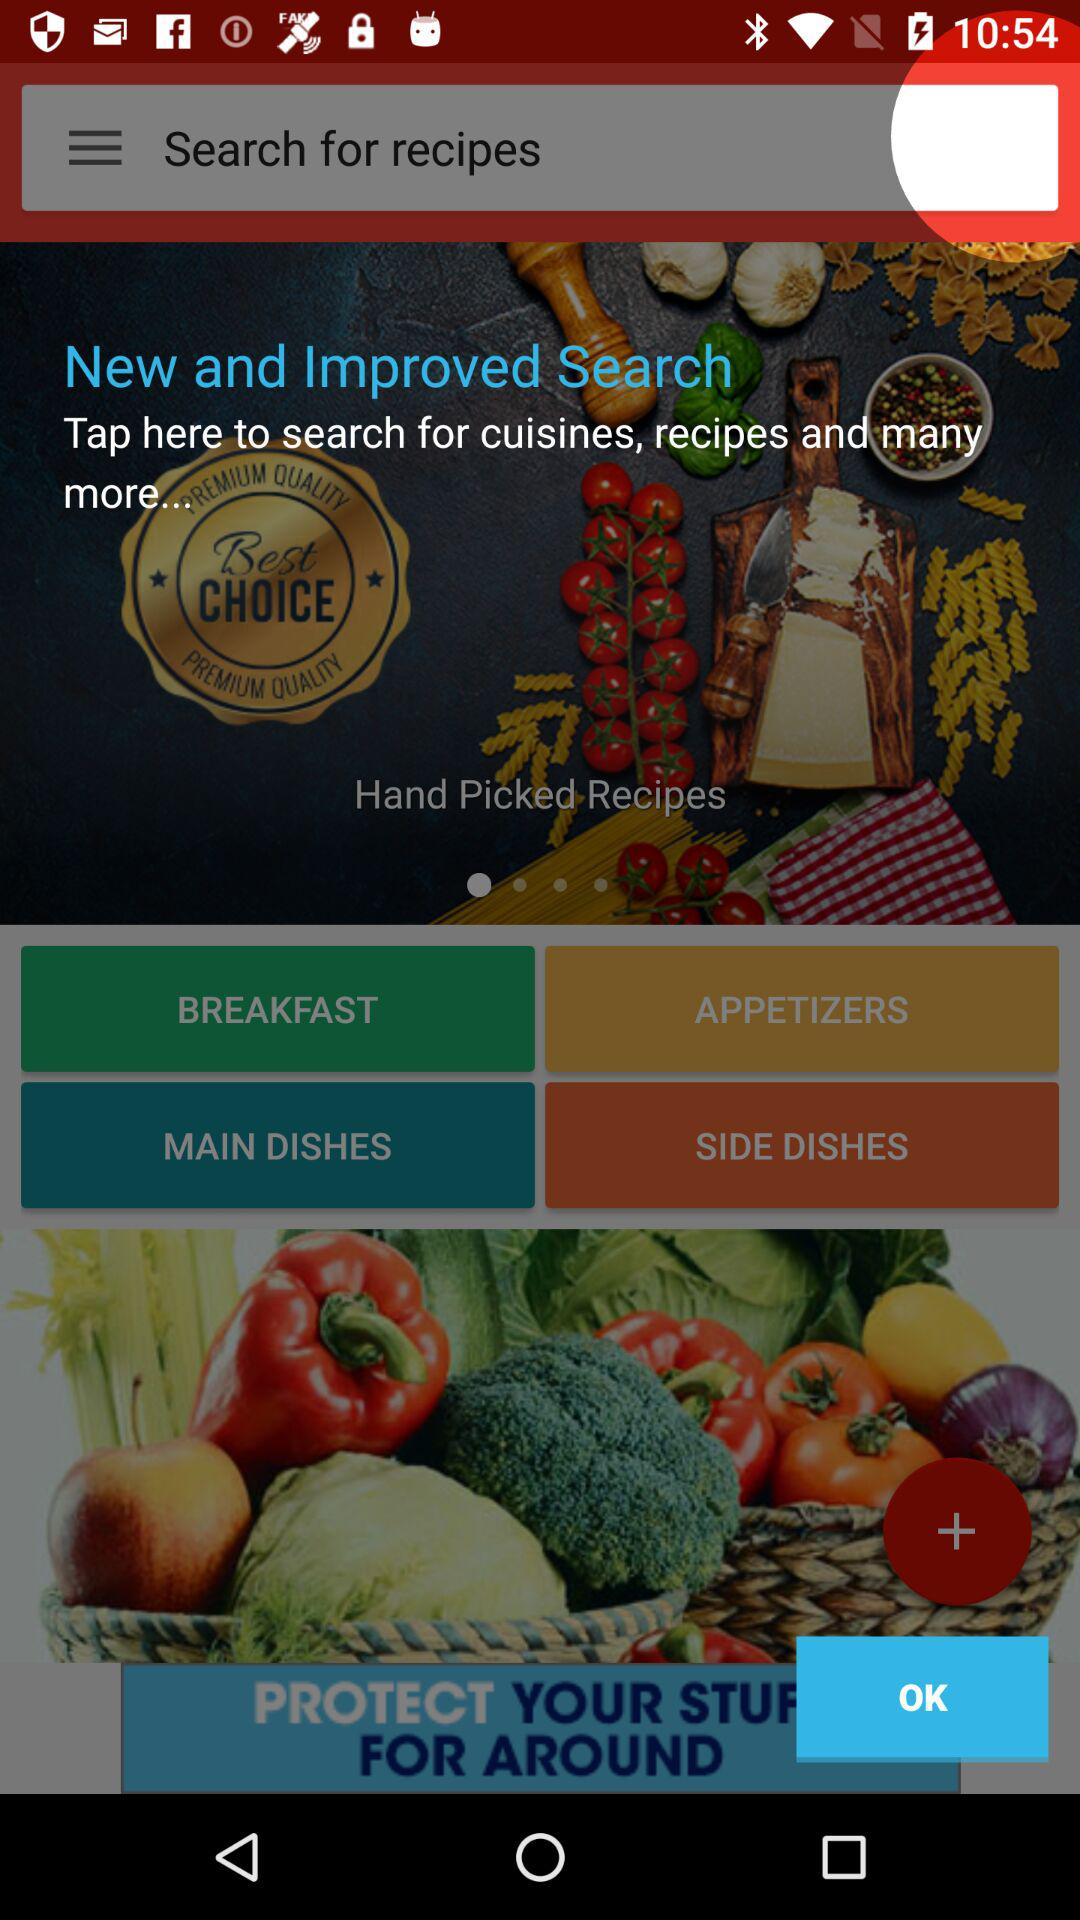What types of dishes do we have? You have "BREAKFAST", "APPETIZERS", "MAIN DISHES" and "SIDE DISHES". 